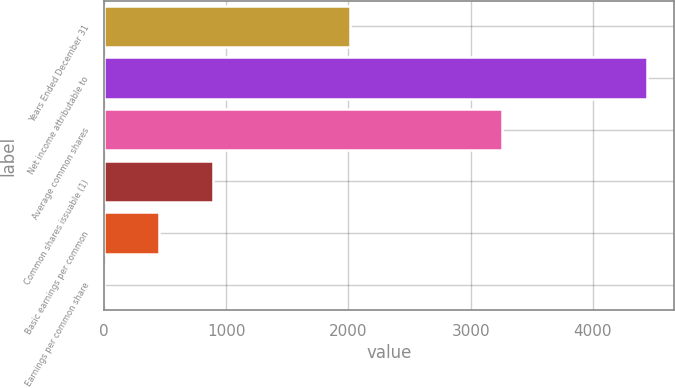<chart> <loc_0><loc_0><loc_500><loc_500><bar_chart><fcel>Years Ended December 31<fcel>Net income attributable to<fcel>Average common shares<fcel>Common shares issuable (1)<fcel>Basic earnings per common<fcel>Earnings per common share<nl><fcel>2015<fcel>4442<fcel>3260.04<fcel>889.64<fcel>445.6<fcel>1.56<nl></chart> 